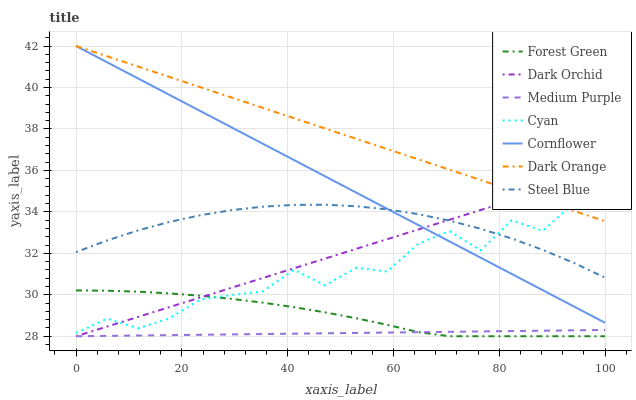Does Medium Purple have the minimum area under the curve?
Answer yes or no. Yes. Does Dark Orange have the maximum area under the curve?
Answer yes or no. Yes. Does Cornflower have the minimum area under the curve?
Answer yes or no. No. Does Cornflower have the maximum area under the curve?
Answer yes or no. No. Is Medium Purple the smoothest?
Answer yes or no. Yes. Is Cyan the roughest?
Answer yes or no. Yes. Is Cornflower the smoothest?
Answer yes or no. No. Is Cornflower the roughest?
Answer yes or no. No. Does Cornflower have the lowest value?
Answer yes or no. No. Does Steel Blue have the highest value?
Answer yes or no. No. Is Forest Green less than Cornflower?
Answer yes or no. Yes. Is Cornflower greater than Medium Purple?
Answer yes or no. Yes. Does Forest Green intersect Cornflower?
Answer yes or no. No. 